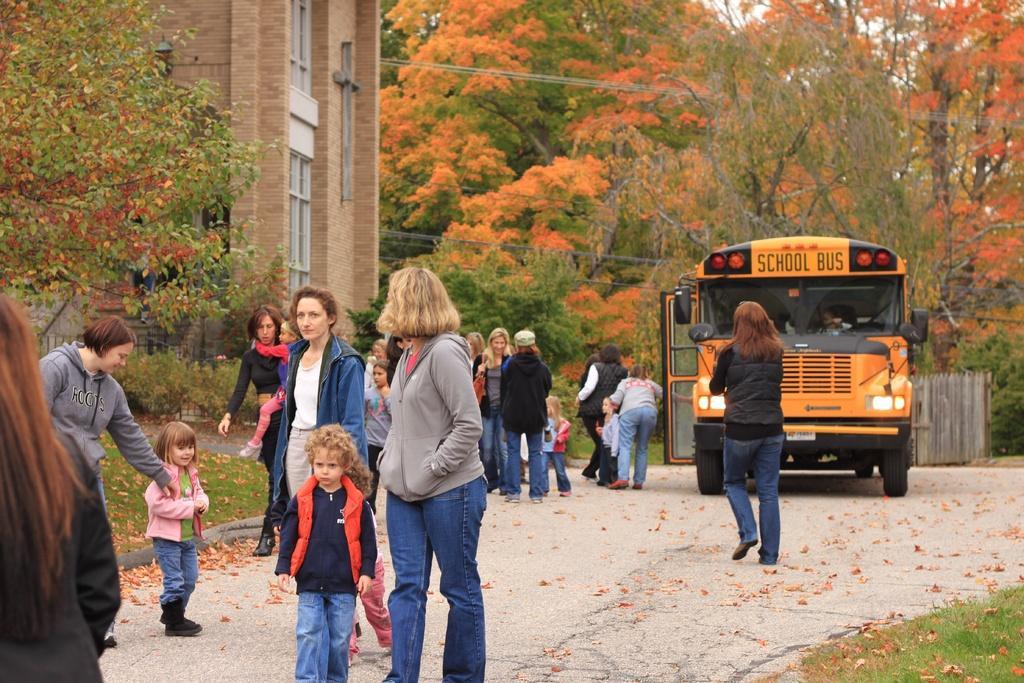In one or two sentences, can you explain what this image depicts? In the image there are few people on the road and behind them there is a school bus, around the people there is grass, trees and a building. 